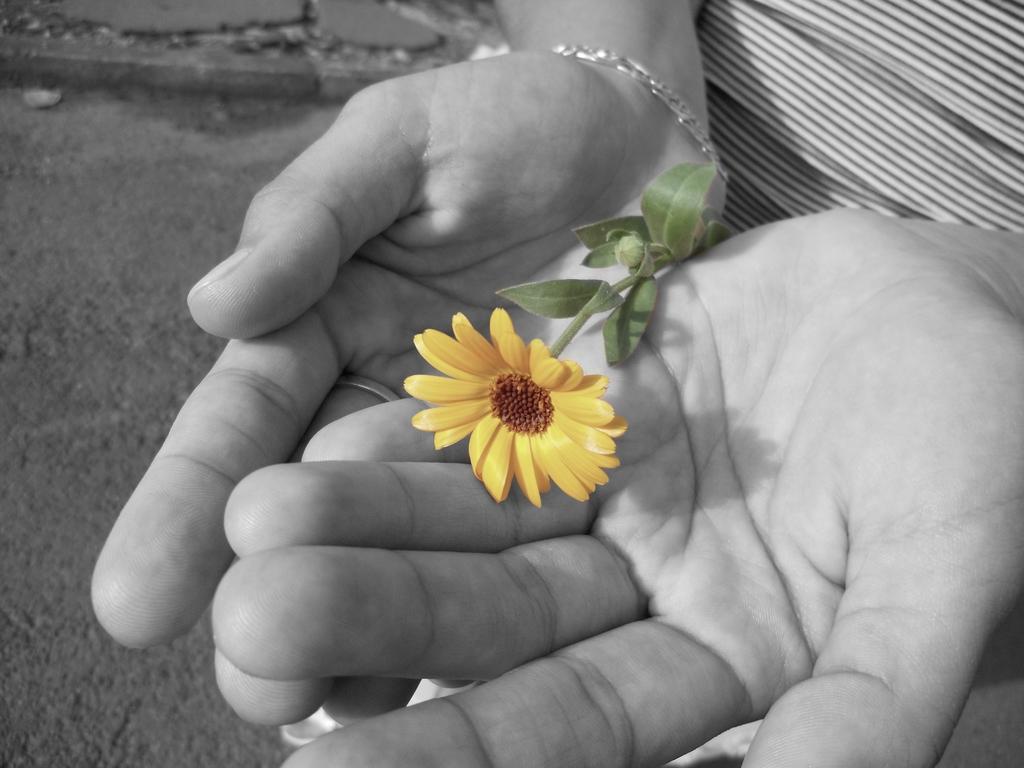Can you describe this image briefly? In this picture I can observe yellow color flower in the human hands. This is a black and white image. 